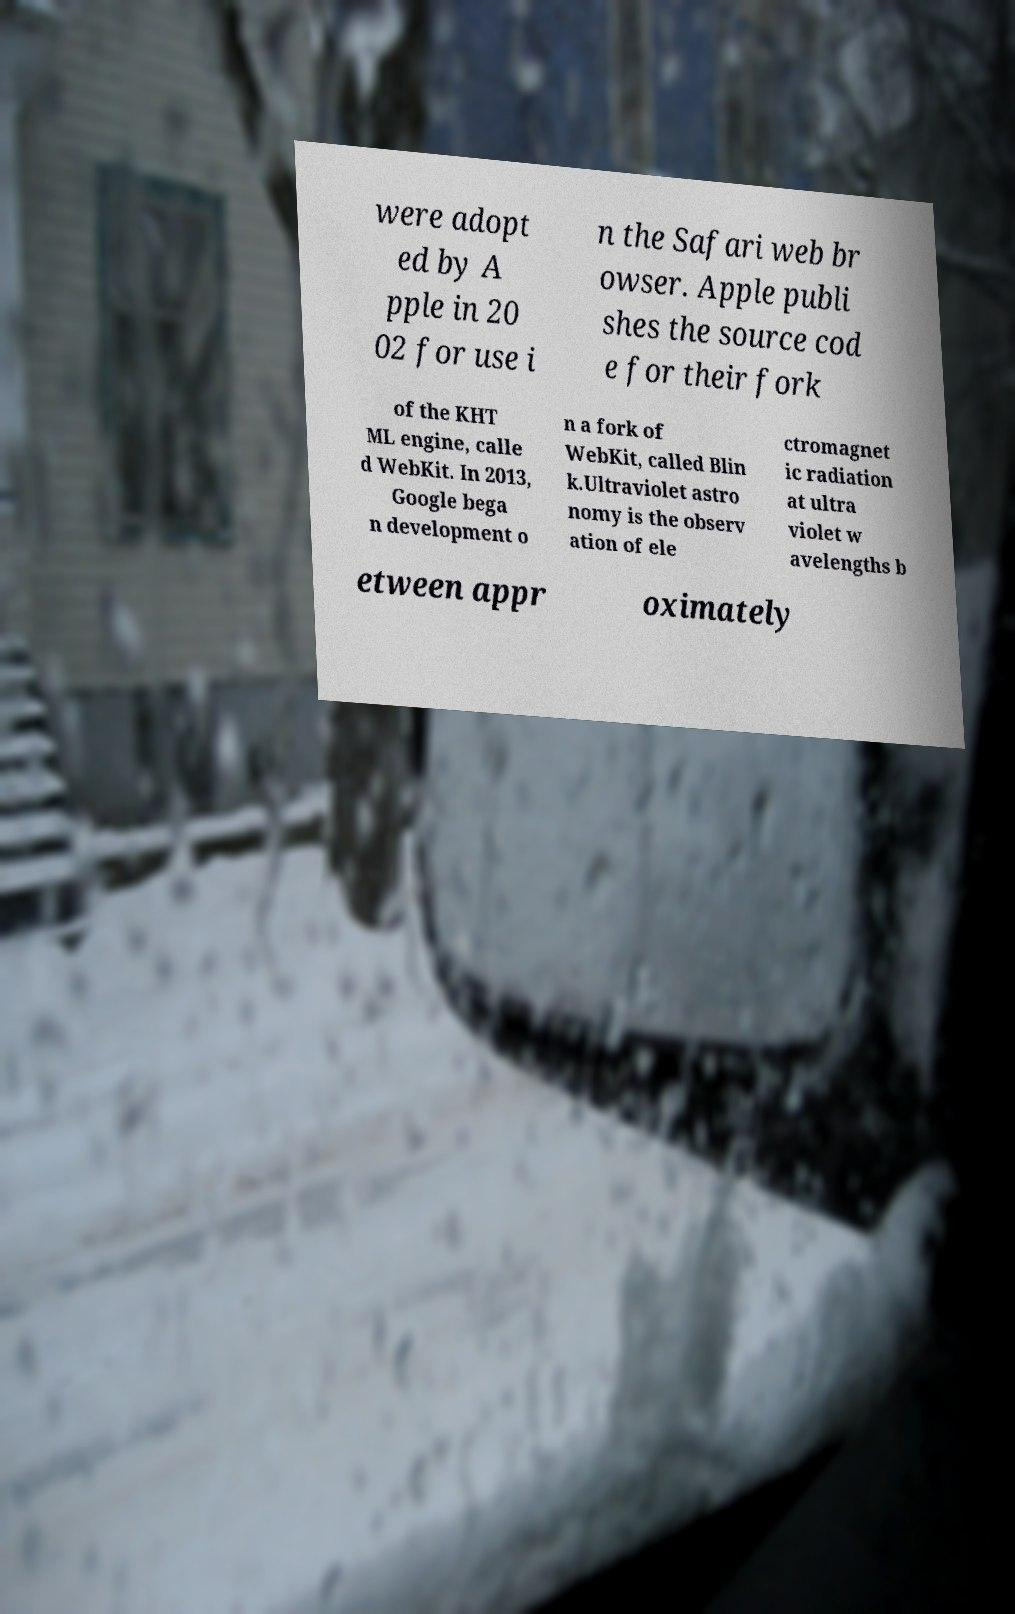Could you assist in decoding the text presented in this image and type it out clearly? were adopt ed by A pple in 20 02 for use i n the Safari web br owser. Apple publi shes the source cod e for their fork of the KHT ML engine, calle d WebKit. In 2013, Google bega n development o n a fork of WebKit, called Blin k.Ultraviolet astro nomy is the observ ation of ele ctromagnet ic radiation at ultra violet w avelengths b etween appr oximately 